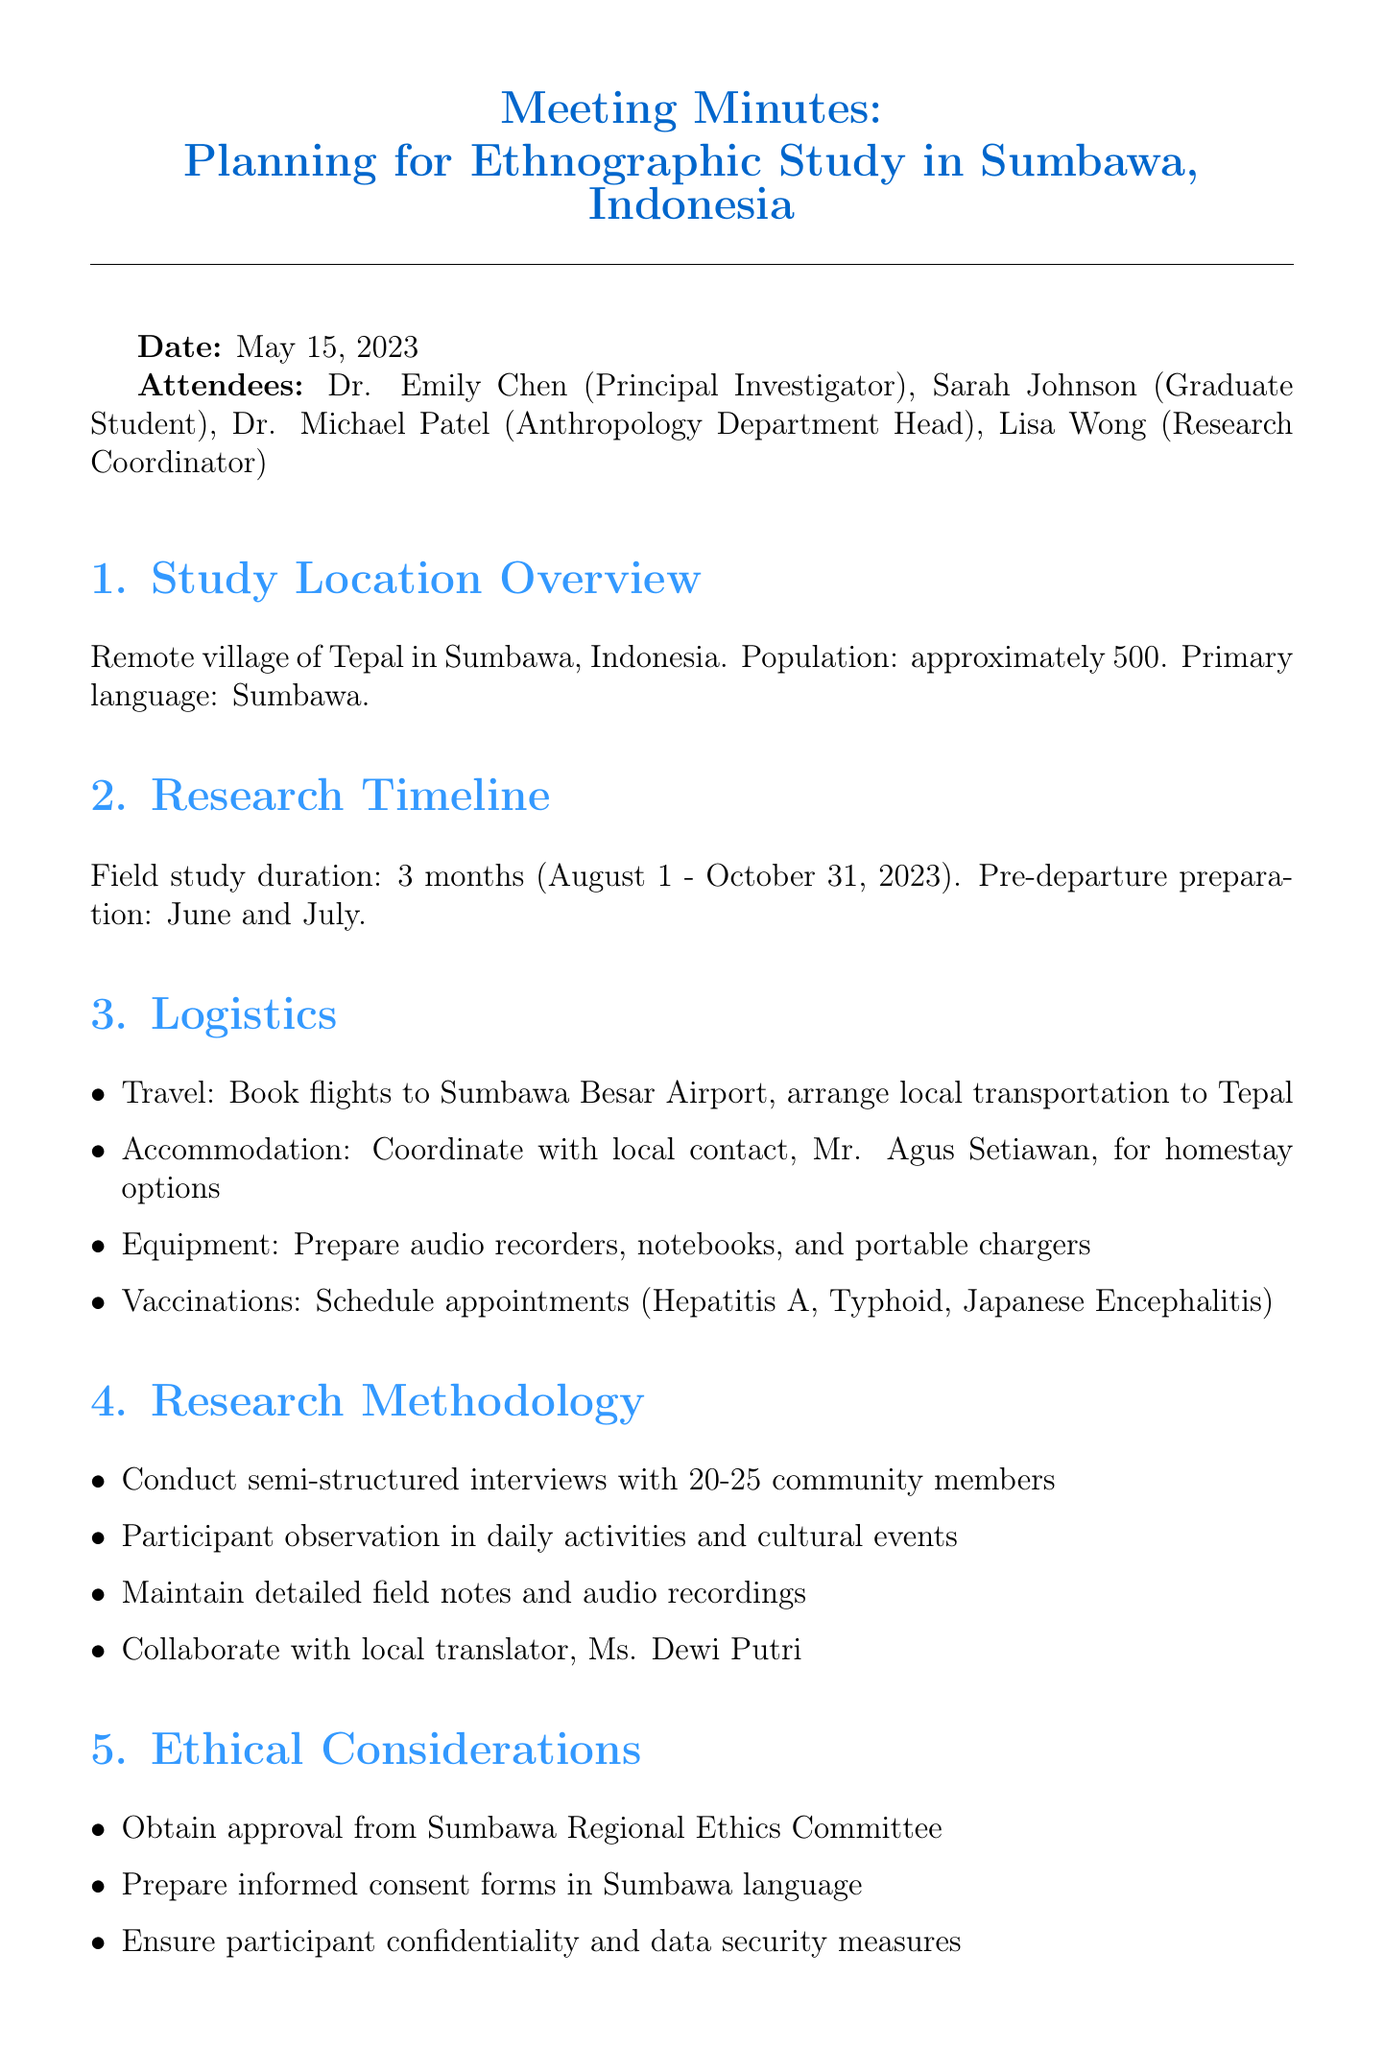What is the title of the meeting? The title of the meeting is provided at the beginning of the document.
Answer: Planning for Ethnographic Study in Sumbawa, Indonesia What is the field study duration? The field study duration is specified in the research timeline section of the document.
Answer: 3 months Who is the local contact for accommodation? The document mentions a specific person to coordinate accommodations for the study.
Answer: Mr. Agus Setiawan What percentage of the budget is allocated for travel? The budget allocation section specifies how much of the total budget is assigned for travel expenses.
Answer: 30% What is the primary language spoken in the study location? The study location overview section indicates the primary language of the community.
Answer: Sumbawa When is the ethics application due? The next steps section outlines deadlines for key tasks related to the study.
Answer: May 25 How many community members will be interviewed? The research methodology section provides the expected number of participants for interviews.
Answer: 20-25 What vaccinations are required for the study? The logistics section lists the necessary health precautions for the research team.
Answer: Hepatitis A, Typhoid, Japanese Encephalitis What is the total budget for the study? The budget allocation section states the total amount allocated for the ethnographic study.
Answer: $12,000 USD 